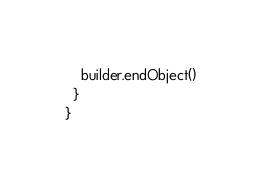<code> <loc_0><loc_0><loc_500><loc_500><_Scala_>    builder.endObject()
  }
}
</code> 